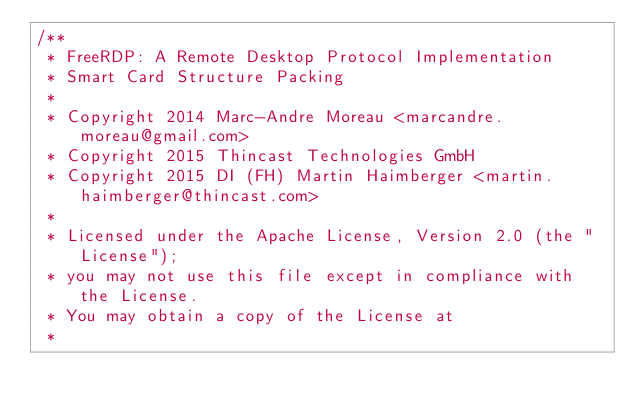Convert code to text. <code><loc_0><loc_0><loc_500><loc_500><_C_>/**
 * FreeRDP: A Remote Desktop Protocol Implementation
 * Smart Card Structure Packing
 *
 * Copyright 2014 Marc-Andre Moreau <marcandre.moreau@gmail.com>
 * Copyright 2015 Thincast Technologies GmbH
 * Copyright 2015 DI (FH) Martin Haimberger <martin.haimberger@thincast.com>
 *
 * Licensed under the Apache License, Version 2.0 (the "License");
 * you may not use this file except in compliance with the License.
 * You may obtain a copy of the License at
 *</code> 